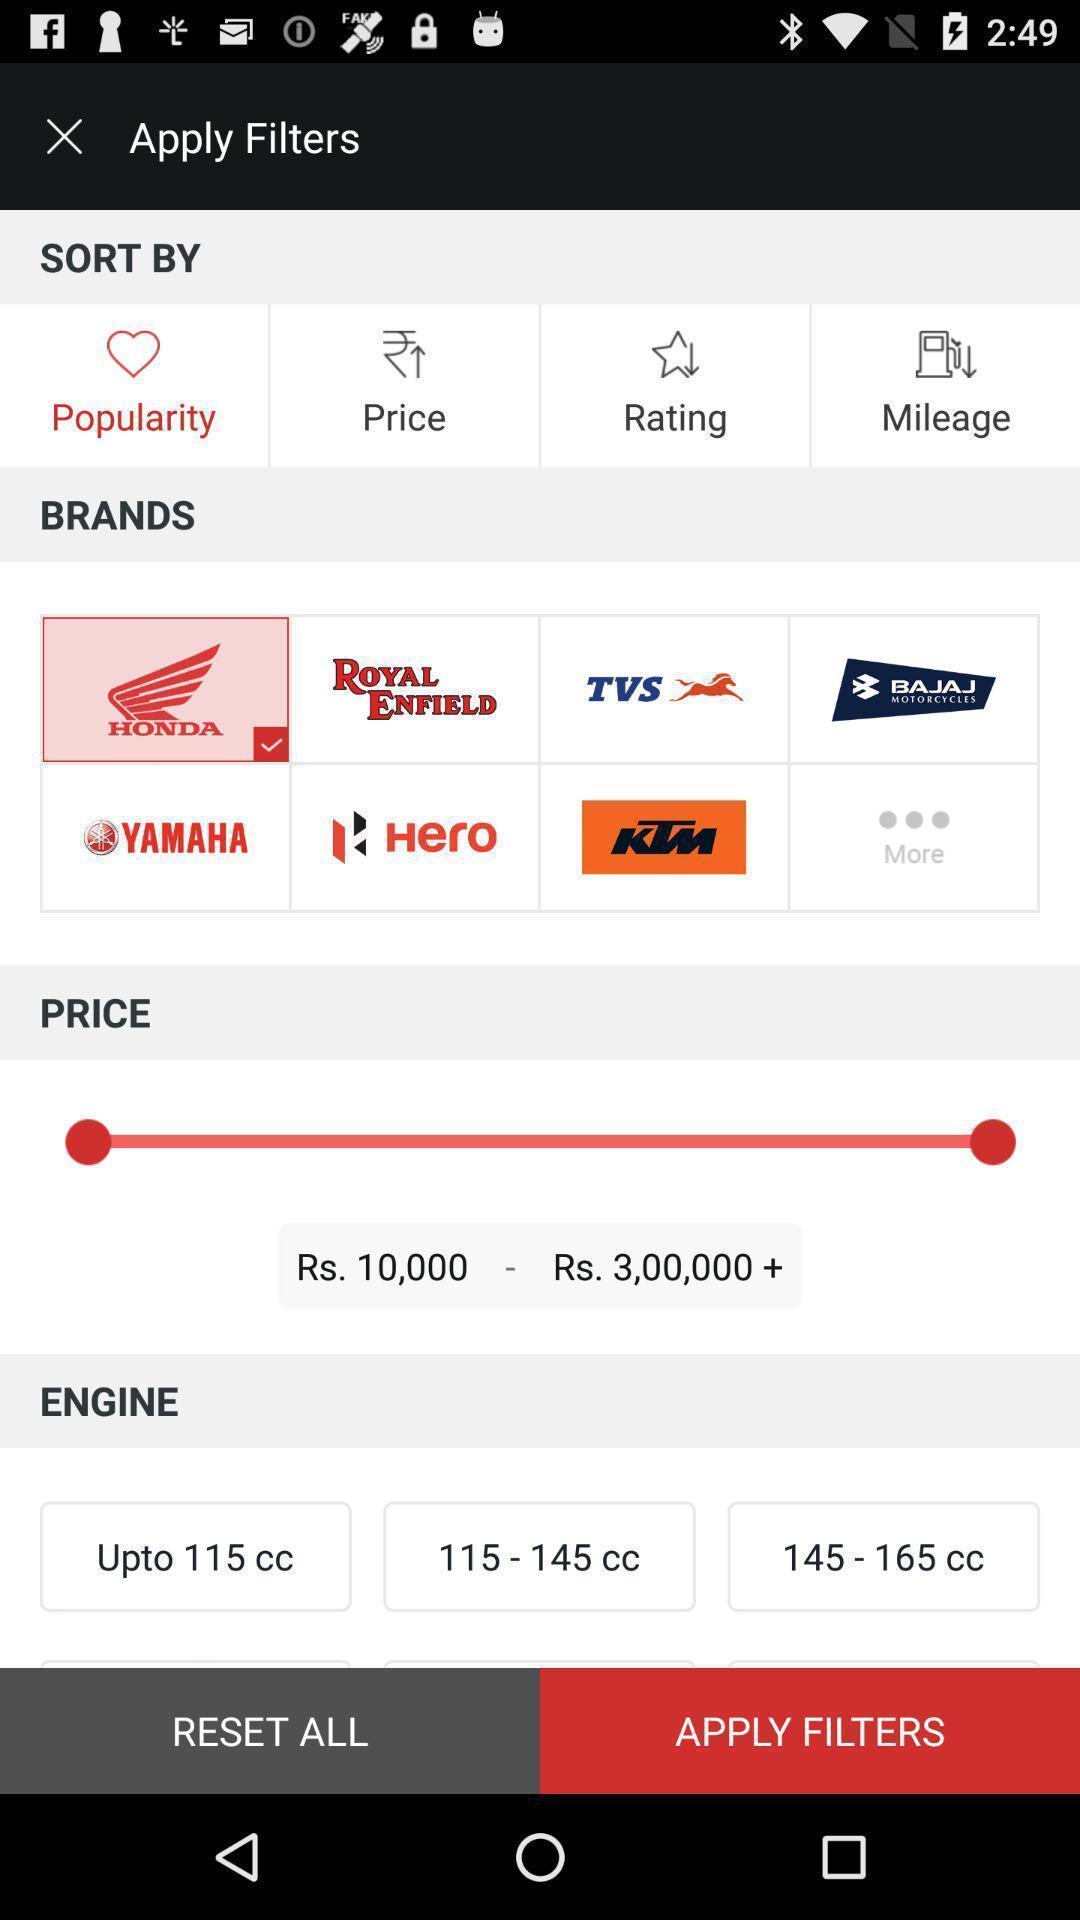Tell me about the visual elements in this screen capture. Shopping app displays different filters to apply. 